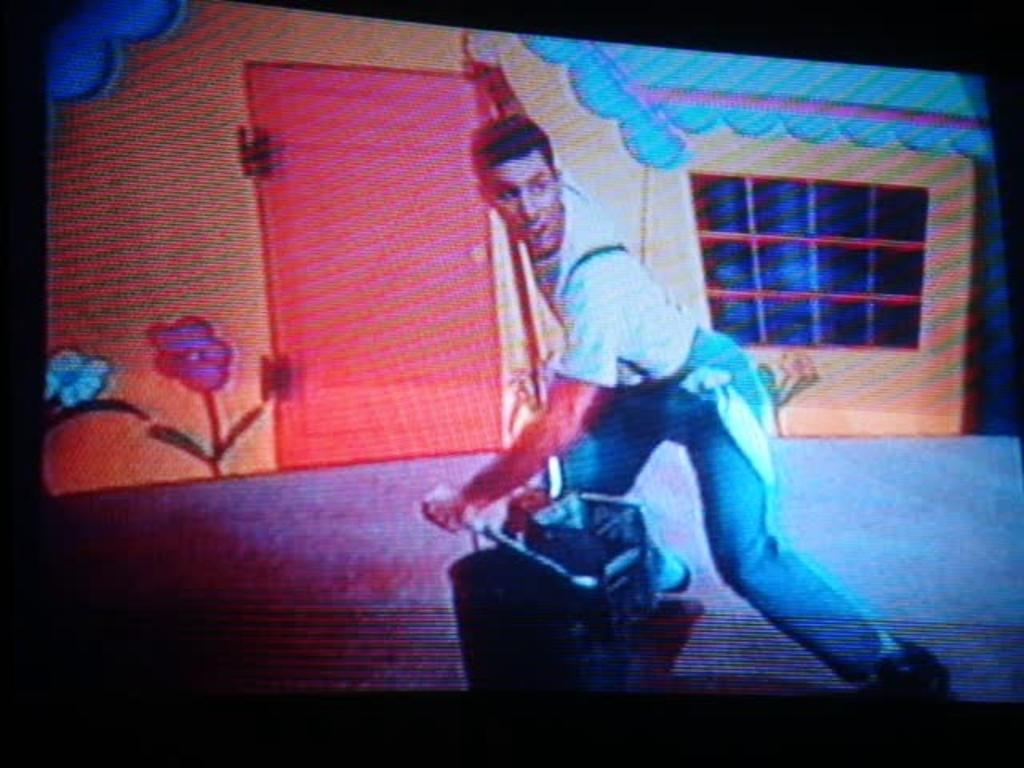What is present in the image? There is a screen in the image. What can be seen on the screen? There is a man visible on the screen. How many rings does the man on the screen have on his fingers? There is no information about rings or the man's fingers in the image, so it cannot be determined. 